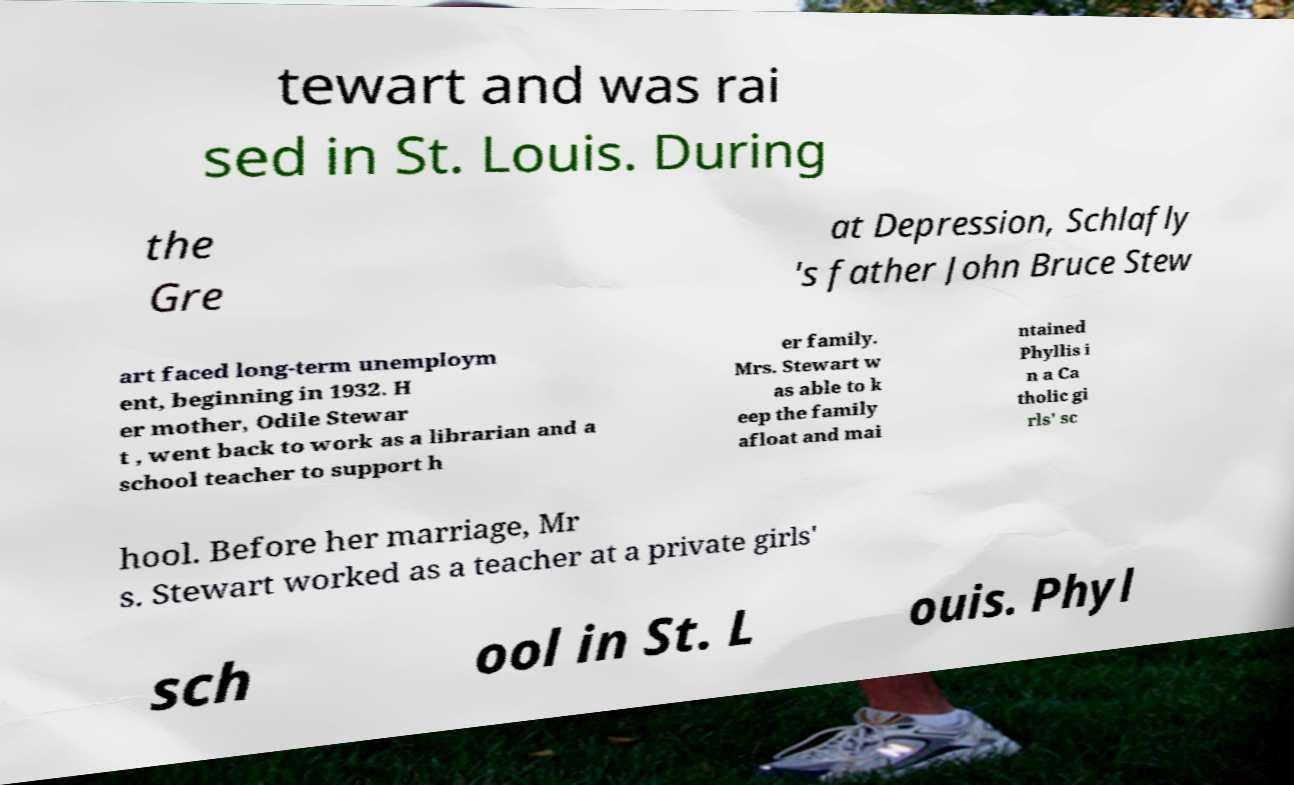For documentation purposes, I need the text within this image transcribed. Could you provide that? tewart and was rai sed in St. Louis. During the Gre at Depression, Schlafly 's father John Bruce Stew art faced long-term unemploym ent, beginning in 1932. H er mother, Odile Stewar t , went back to work as a librarian and a school teacher to support h er family. Mrs. Stewart w as able to k eep the family afloat and mai ntained Phyllis i n a Ca tholic gi rls' sc hool. Before her marriage, Mr s. Stewart worked as a teacher at a private girls' sch ool in St. L ouis. Phyl 